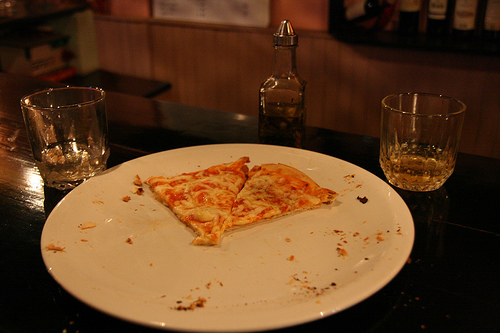Are there either any soda cans or coffee cups in this photo? No, there are no soda cans or coffee cups present in this photo, just a couple of glass tumblers, one of which appears to contain a clear liquid. 